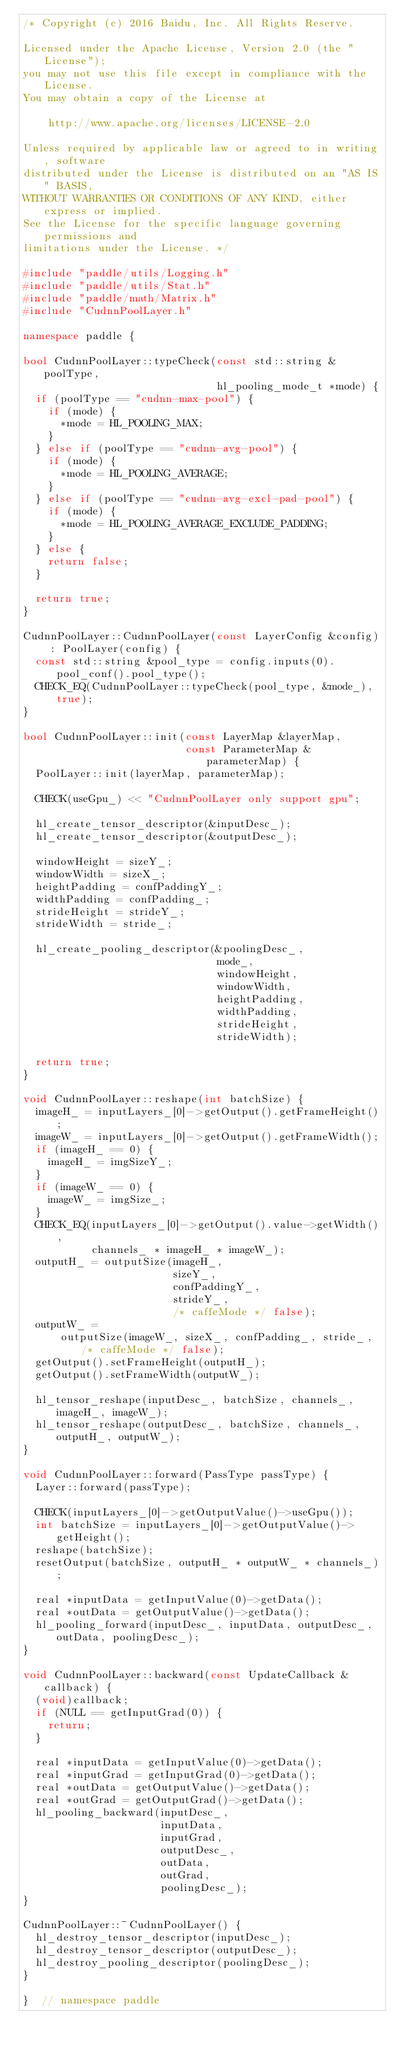Convert code to text. <code><loc_0><loc_0><loc_500><loc_500><_C++_>/* Copyright (c) 2016 Baidu, Inc. All Rights Reserve.

Licensed under the Apache License, Version 2.0 (the "License");
you may not use this file except in compliance with the License.
You may obtain a copy of the License at

    http://www.apache.org/licenses/LICENSE-2.0

Unless required by applicable law or agreed to in writing, software
distributed under the License is distributed on an "AS IS" BASIS,
WITHOUT WARRANTIES OR CONDITIONS OF ANY KIND, either express or implied.
See the License for the specific language governing permissions and
limitations under the License. */

#include "paddle/utils/Logging.h"
#include "paddle/utils/Stat.h"
#include "paddle/math/Matrix.h"
#include "CudnnPoolLayer.h"

namespace paddle {

bool CudnnPoolLayer::typeCheck(const std::string &poolType,
                               hl_pooling_mode_t *mode) {
  if (poolType == "cudnn-max-pool") {
    if (mode) {
      *mode = HL_POOLING_MAX;
    }
  } else if (poolType == "cudnn-avg-pool") {
    if (mode) {
      *mode = HL_POOLING_AVERAGE;
    }
  } else if (poolType == "cudnn-avg-excl-pad-pool") {
    if (mode) {
      *mode = HL_POOLING_AVERAGE_EXCLUDE_PADDING;
    }
  } else {
    return false;
  }

  return true;
}

CudnnPoolLayer::CudnnPoolLayer(const LayerConfig &config) : PoolLayer(config) {
  const std::string &pool_type = config.inputs(0).pool_conf().pool_type();
  CHECK_EQ(CudnnPoolLayer::typeCheck(pool_type, &mode_), true);
}

bool CudnnPoolLayer::init(const LayerMap &layerMap,
                          const ParameterMap &parameterMap) {
  PoolLayer::init(layerMap, parameterMap);

  CHECK(useGpu_) << "CudnnPoolLayer only support gpu";

  hl_create_tensor_descriptor(&inputDesc_);
  hl_create_tensor_descriptor(&outputDesc_);

  windowHeight = sizeY_;
  windowWidth = sizeX_;
  heightPadding = confPaddingY_;
  widthPadding = confPadding_;
  strideHeight = strideY_;
  strideWidth = stride_;

  hl_create_pooling_descriptor(&poolingDesc_,
                               mode_,
                               windowHeight,
                               windowWidth,
                               heightPadding,
                               widthPadding,
                               strideHeight,
                               strideWidth);

  return true;
}

void CudnnPoolLayer::reshape(int batchSize) {
  imageH_ = inputLayers_[0]->getOutput().getFrameHeight();
  imageW_ = inputLayers_[0]->getOutput().getFrameWidth();
  if (imageH_ == 0) {
    imageH_ = imgSizeY_;
  }
  if (imageW_ == 0) {
    imageW_ = imgSize_;
  }
  CHECK_EQ(inputLayers_[0]->getOutput().value->getWidth(),
           channels_ * imageH_ * imageW_);
  outputH_ = outputSize(imageH_,
                        sizeY_,
                        confPaddingY_,
                        strideY_,
                        /* caffeMode */ false);
  outputW_ =
      outputSize(imageW_, sizeX_, confPadding_, stride_, /* caffeMode */ false);
  getOutput().setFrameHeight(outputH_);
  getOutput().setFrameWidth(outputW_);

  hl_tensor_reshape(inputDesc_, batchSize, channels_, imageH_, imageW_);
  hl_tensor_reshape(outputDesc_, batchSize, channels_, outputH_, outputW_);
}

void CudnnPoolLayer::forward(PassType passType) {
  Layer::forward(passType);

  CHECK(inputLayers_[0]->getOutputValue()->useGpu());
  int batchSize = inputLayers_[0]->getOutputValue()->getHeight();
  reshape(batchSize);
  resetOutput(batchSize, outputH_ * outputW_ * channels_);

  real *inputData = getInputValue(0)->getData();
  real *outData = getOutputValue()->getData();
  hl_pooling_forward(inputDesc_, inputData, outputDesc_, outData, poolingDesc_);
}

void CudnnPoolLayer::backward(const UpdateCallback &callback) {
  (void)callback;
  if (NULL == getInputGrad(0)) {
    return;
  }

  real *inputData = getInputValue(0)->getData();
  real *inputGrad = getInputGrad(0)->getData();
  real *outData = getOutputValue()->getData();
  real *outGrad = getOutputGrad()->getData();
  hl_pooling_backward(inputDesc_,
                      inputData,
                      inputGrad,
                      outputDesc_,
                      outData,
                      outGrad,
                      poolingDesc_);
}

CudnnPoolLayer::~CudnnPoolLayer() {
  hl_destroy_tensor_descriptor(inputDesc_);
  hl_destroy_tensor_descriptor(outputDesc_);
  hl_destroy_pooling_descriptor(poolingDesc_);
}

}  // namespace paddle
</code> 